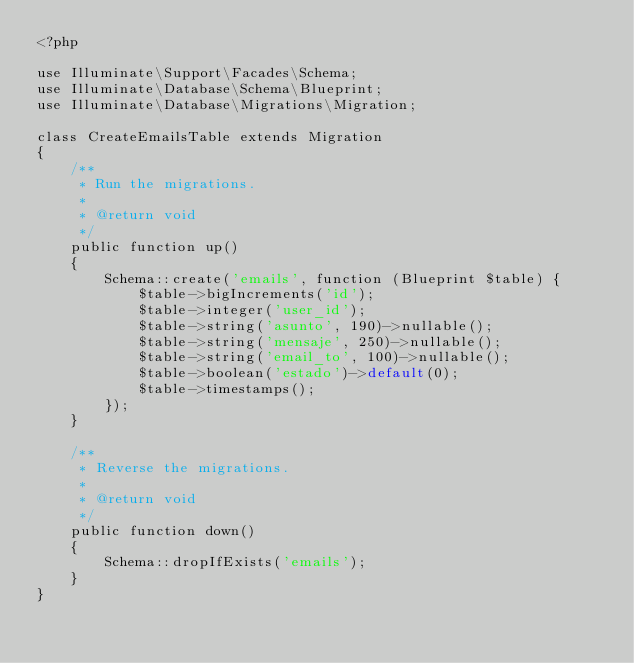Convert code to text. <code><loc_0><loc_0><loc_500><loc_500><_PHP_><?php

use Illuminate\Support\Facades\Schema;
use Illuminate\Database\Schema\Blueprint;
use Illuminate\Database\Migrations\Migration;

class CreateEmailsTable extends Migration
{
    /**
     * Run the migrations.
     *
     * @return void
     */
    public function up()
    {
        Schema::create('emails', function (Blueprint $table) {
            $table->bigIncrements('id');
            $table->integer('user_id');
            $table->string('asunto', 190)->nullable();
            $table->string('mensaje', 250)->nullable();
            $table->string('email_to', 100)->nullable();
            $table->boolean('estado')->default(0);
            $table->timestamps();
        });
    }

    /**
     * Reverse the migrations.
     *
     * @return void
     */
    public function down()
    {
        Schema::dropIfExists('emails');
    }
}
</code> 